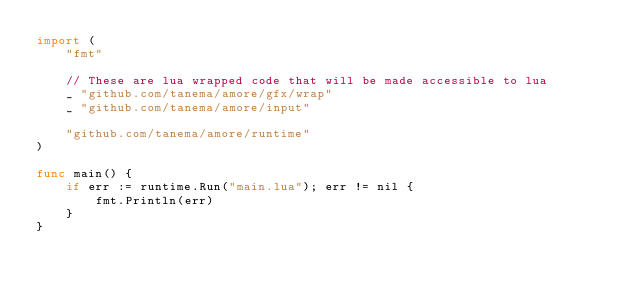<code> <loc_0><loc_0><loc_500><loc_500><_Go_>import (
	"fmt"

	// These are lua wrapped code that will be made accessible to lua
	_ "github.com/tanema/amore/gfx/wrap"
	_ "github.com/tanema/amore/input"

	"github.com/tanema/amore/runtime"
)

func main() {
	if err := runtime.Run("main.lua"); err != nil {
		fmt.Println(err)
	}
}
</code> 